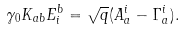<formula> <loc_0><loc_0><loc_500><loc_500>\gamma _ { 0 } K _ { a b } E ^ { b } _ { i } = { \sqrt { q } } ( A _ { a } ^ { i } - \Gamma _ { a } ^ { i } ) .</formula> 